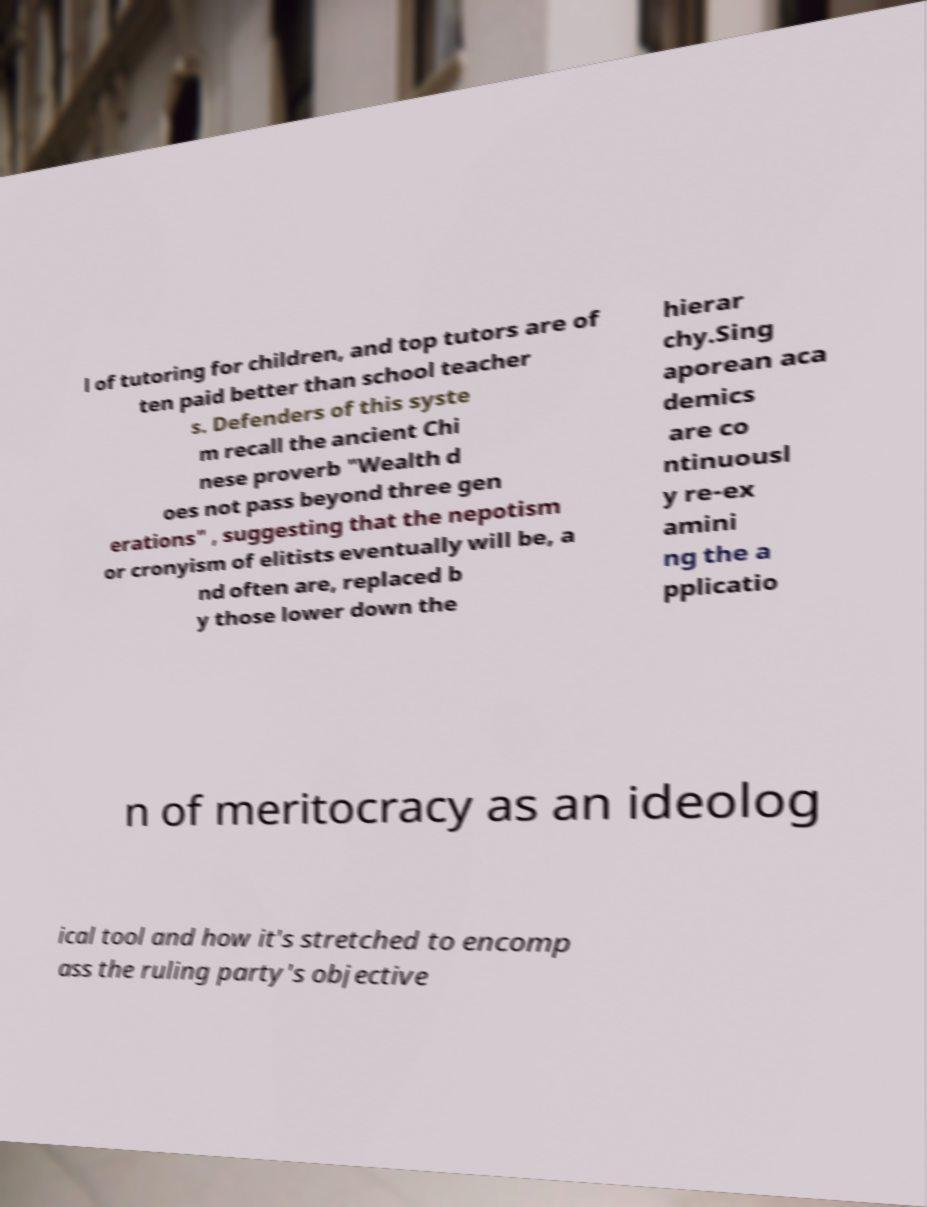Can you accurately transcribe the text from the provided image for me? l of tutoring for children, and top tutors are of ten paid better than school teacher s. Defenders of this syste m recall the ancient Chi nese proverb "Wealth d oes not pass beyond three gen erations" , suggesting that the nepotism or cronyism of elitists eventually will be, a nd often are, replaced b y those lower down the hierar chy.Sing aporean aca demics are co ntinuousl y re-ex amini ng the a pplicatio n of meritocracy as an ideolog ical tool and how it's stretched to encomp ass the ruling party's objective 